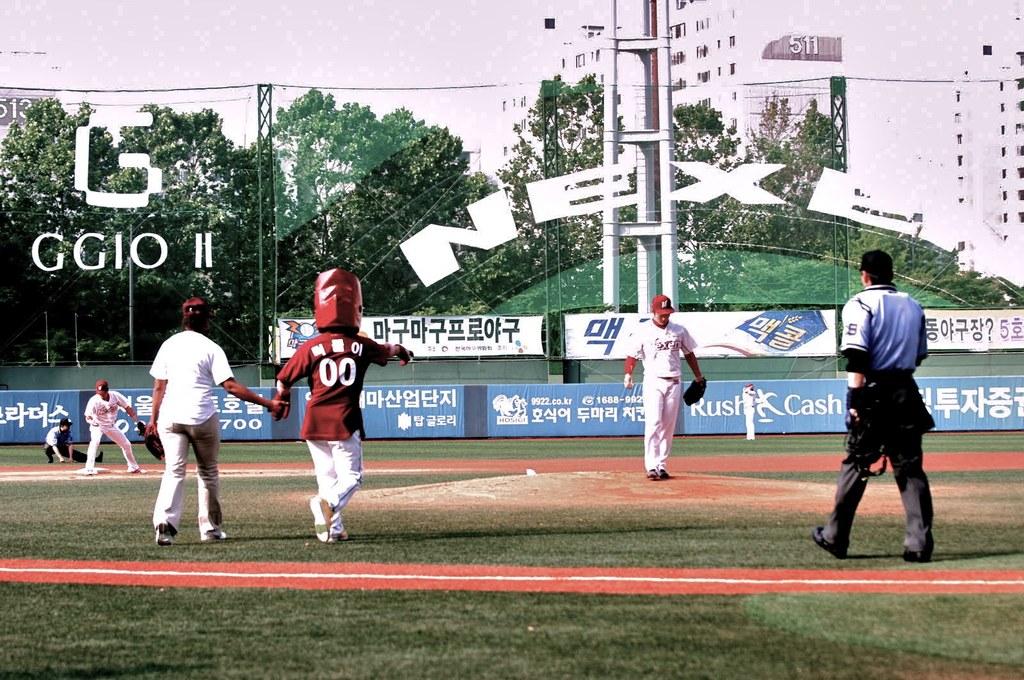What type of cash is in the outfield?
Your response must be concise. Rush. 